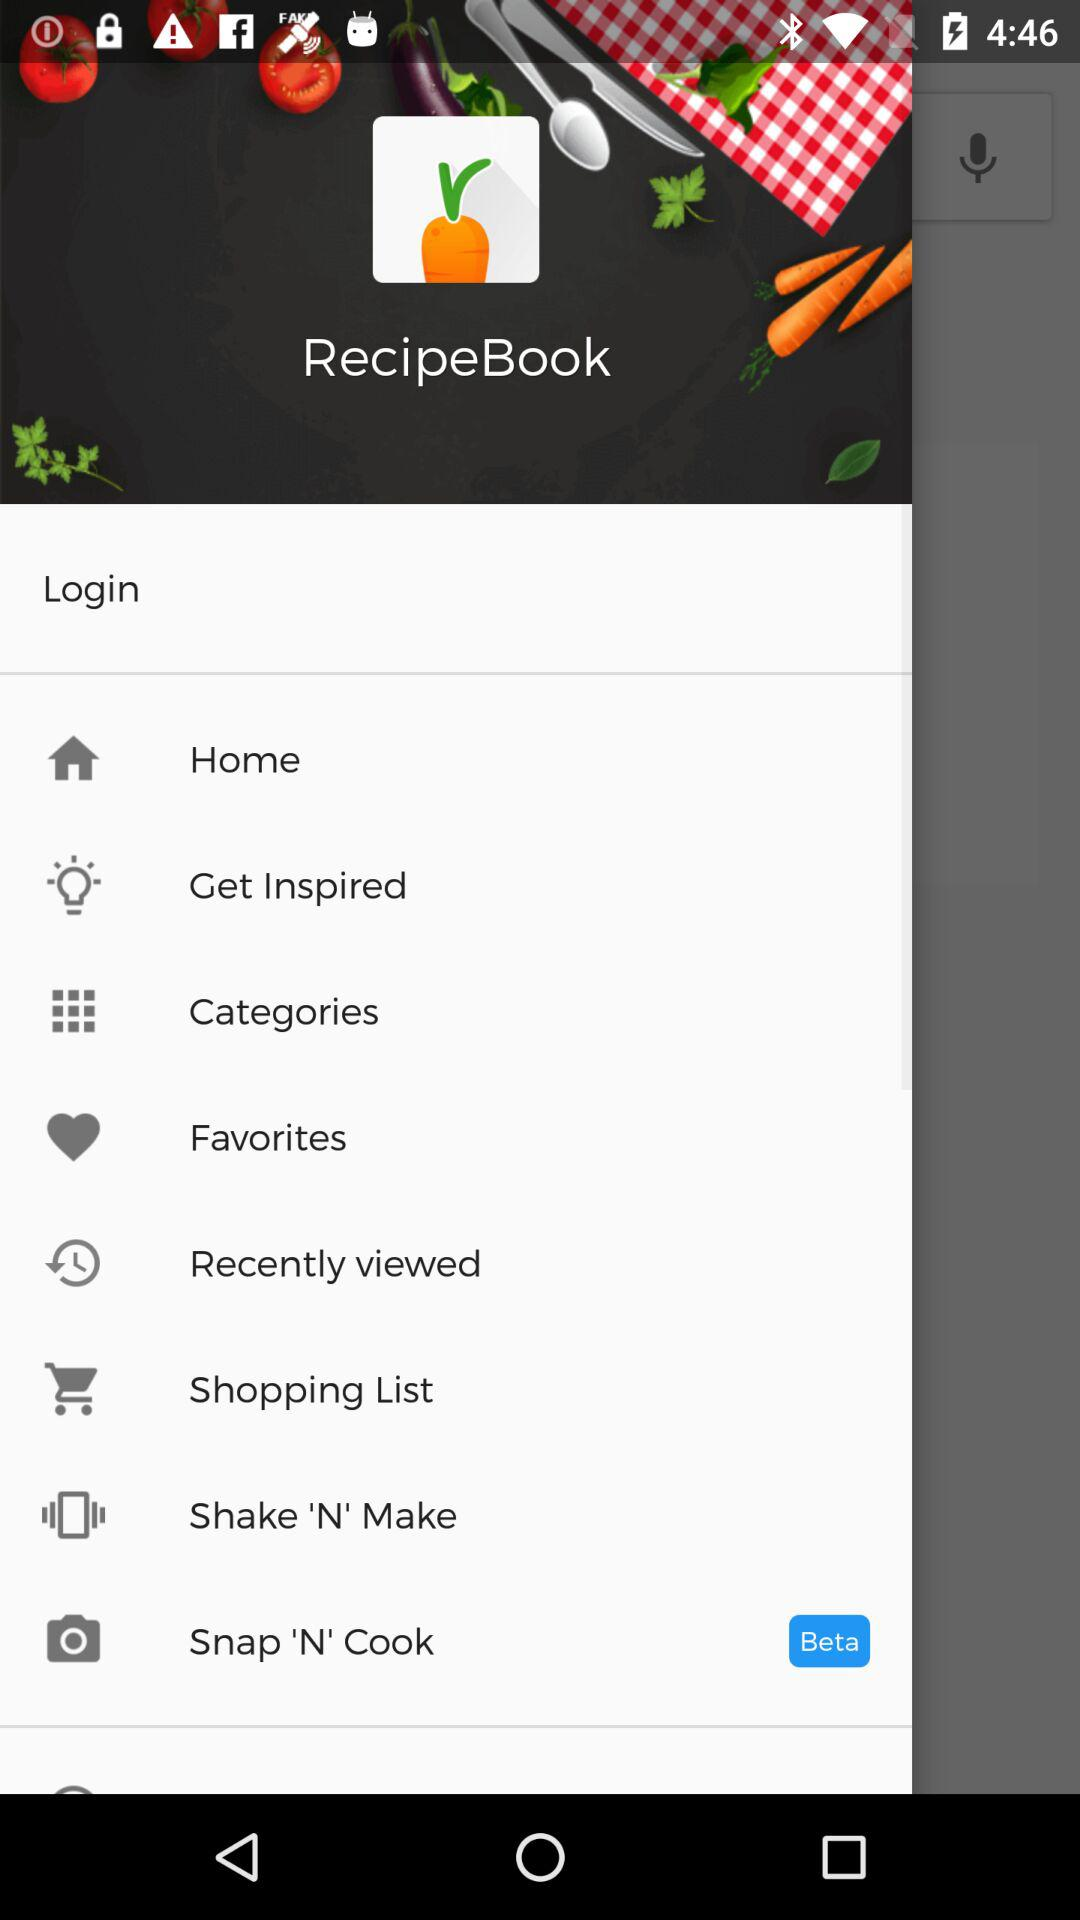What option is selected as "Beta"? The selected option is "Snap 'N' Cook". 